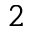<formula> <loc_0><loc_0><loc_500><loc_500>2</formula> 